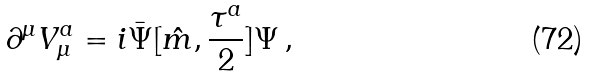<formula> <loc_0><loc_0><loc_500><loc_500>\partial ^ { \mu } V _ { \mu } ^ { a } = i \bar { \Psi } [ { \hat { m } } , { \frac { \tau ^ { a } } { 2 } } ] \Psi \, ,</formula> 